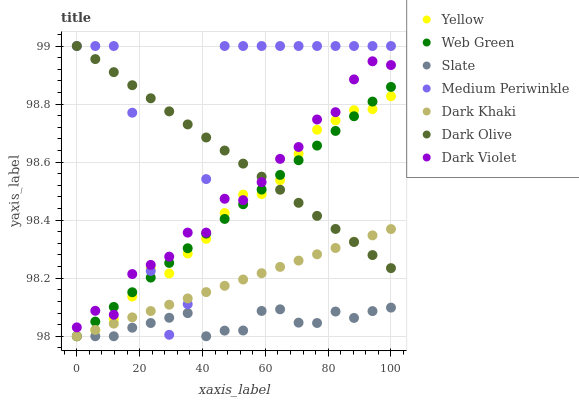Does Slate have the minimum area under the curve?
Answer yes or no. Yes. Does Medium Periwinkle have the maximum area under the curve?
Answer yes or no. Yes. Does Dark Olive have the minimum area under the curve?
Answer yes or no. No. Does Dark Olive have the maximum area under the curve?
Answer yes or no. No. Is Dark Olive the smoothest?
Answer yes or no. Yes. Is Medium Periwinkle the roughest?
Answer yes or no. Yes. Is Slate the smoothest?
Answer yes or no. No. Is Slate the roughest?
Answer yes or no. No. Does Slate have the lowest value?
Answer yes or no. Yes. Does Dark Olive have the lowest value?
Answer yes or no. No. Does Medium Periwinkle have the highest value?
Answer yes or no. Yes. Does Slate have the highest value?
Answer yes or no. No. Is Slate less than Dark Violet?
Answer yes or no. Yes. Is Dark Violet greater than Slate?
Answer yes or no. Yes. Does Dark Violet intersect Yellow?
Answer yes or no. Yes. Is Dark Violet less than Yellow?
Answer yes or no. No. Is Dark Violet greater than Yellow?
Answer yes or no. No. Does Slate intersect Dark Violet?
Answer yes or no. No. 